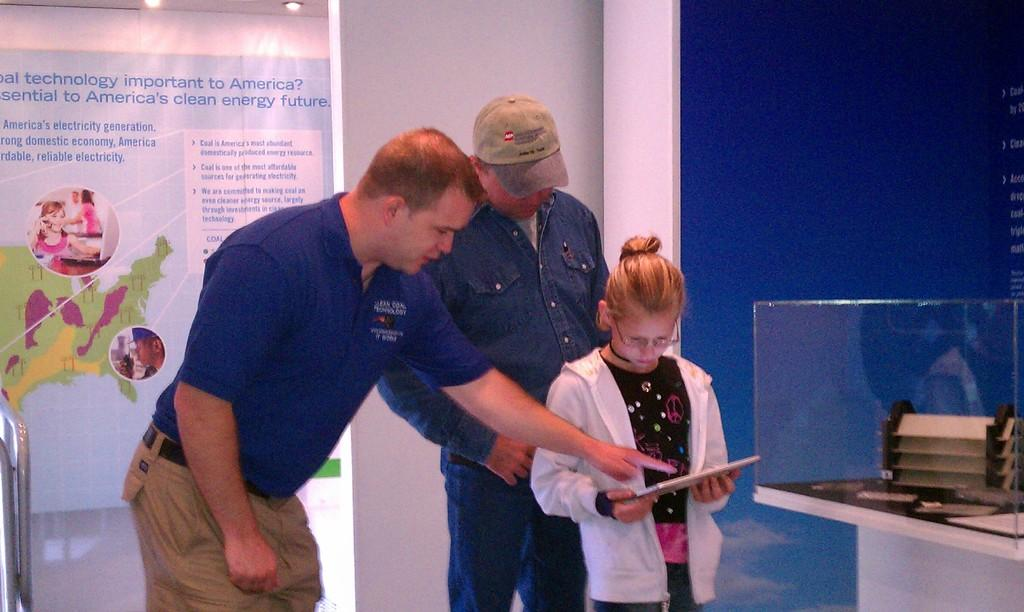<image>
Summarize the visual content of the image. A man wearing a blue shirt that says technology shows a girl how to use an iPad. 